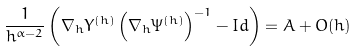<formula> <loc_0><loc_0><loc_500><loc_500>\frac { 1 } { h ^ { \alpha - 2 } } \left ( \nabla _ { h } Y ^ { ( h ) } \left ( \nabla _ { h } \Psi ^ { ( h ) } \right ) ^ { - 1 } - I d \right ) = A + O ( h )</formula> 